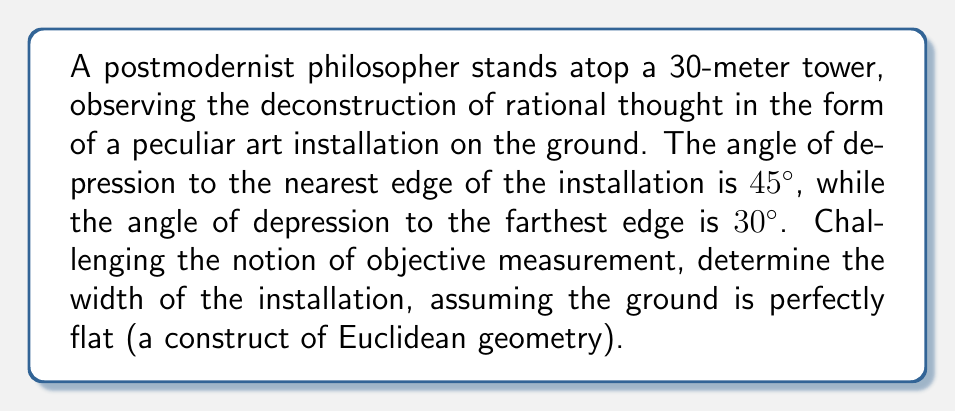Provide a solution to this math problem. Let's approach this problem while acknowledging the inherent subjectivity of perspective:

1) First, we'll consider the two right triangles formed by the philosopher's line of sight to the edges of the installation:

[asy]
import geometry;

size(200);

pair A = (0,0), B = (30,30), C = (60,0), D = (90,0);
draw(A--B--D--A);
draw(B--C);
label("30m", B, N);
label("x", C--D, S);
label("y", A--C, S);
label("45°", B, SW);
label("30°", B, SE);
[/asy]

2) In the triangle with the 45° angle of depression:
   $\tan 45° = \frac{30}{y}$
   where $y$ is the distance from the base of the tower to the nearest edge.

3) We know that $\tan 45° = 1$, so:
   $1 = \frac{30}{y}$
   $y = 30$ meters

4) In the triangle with the 30° angle of depression:
   $\tan 30° = \frac{30}{y+x}$
   where $x$ is the width of the installation.

5) We know that $\tan 30° = \frac{1}{\sqrt{3}}$, so:
   $\frac{1}{\sqrt{3}} = \frac{30}{y+x}$
   $y + x = 30\sqrt{3}$

6) Substituting the value of $y$ we found earlier:
   $30 + x = 30\sqrt{3}$
   $x = 30\sqrt{3} - 30$
   $x = 30(\sqrt{3} - 1)$

7) Simplifying:
   $x \approx 21.96$ meters

However, as a postmodernist philosopher, we must question whether this "width" has any inherent meaning beyond our subjective interpretation and the arbitrary constructs of mathematics.
Answer: $30(\sqrt{3} - 1)$ meters 